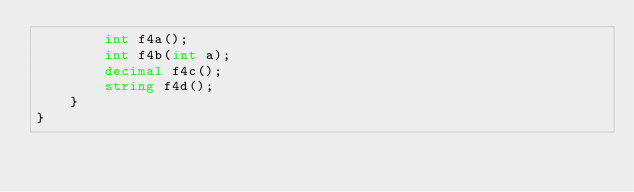<code> <loc_0><loc_0><loc_500><loc_500><_C#_>        int f4a();
        int f4b(int a);
        decimal f4c();
        string f4d();
    }
}
</code> 